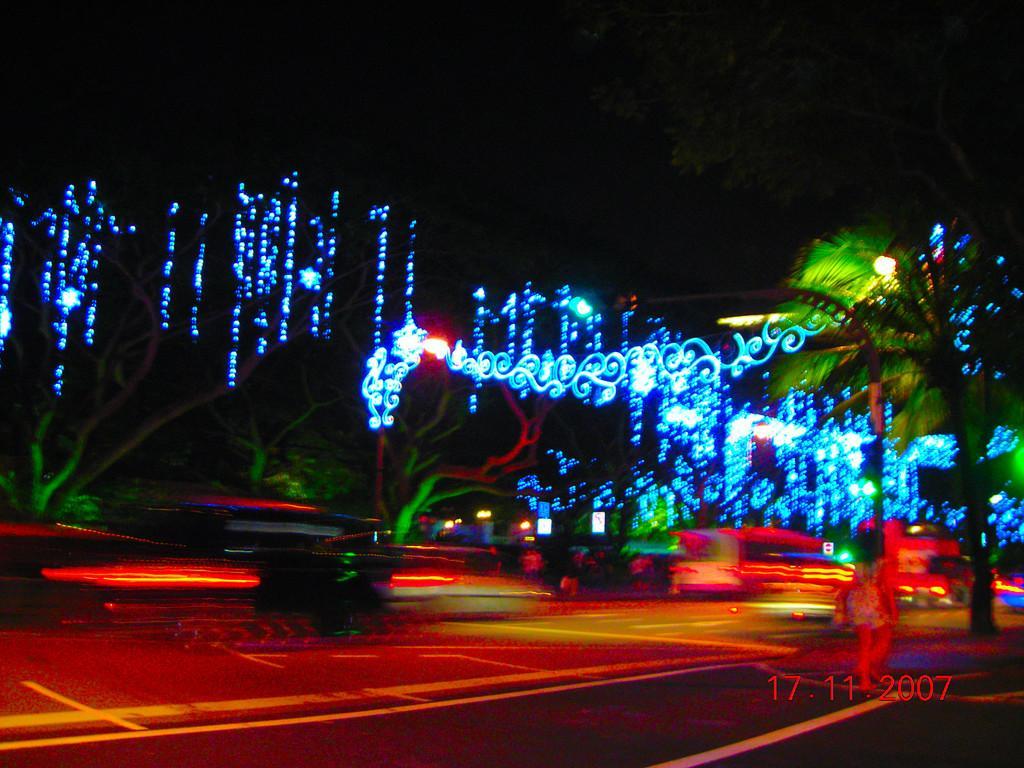Describe this image in one or two sentences. This picture is slightly blurred, which is taken in the dark. Here we can see a person is walking on the road, we can see lights and trees. Here we can see the watermark on the bottom right side of the image. 